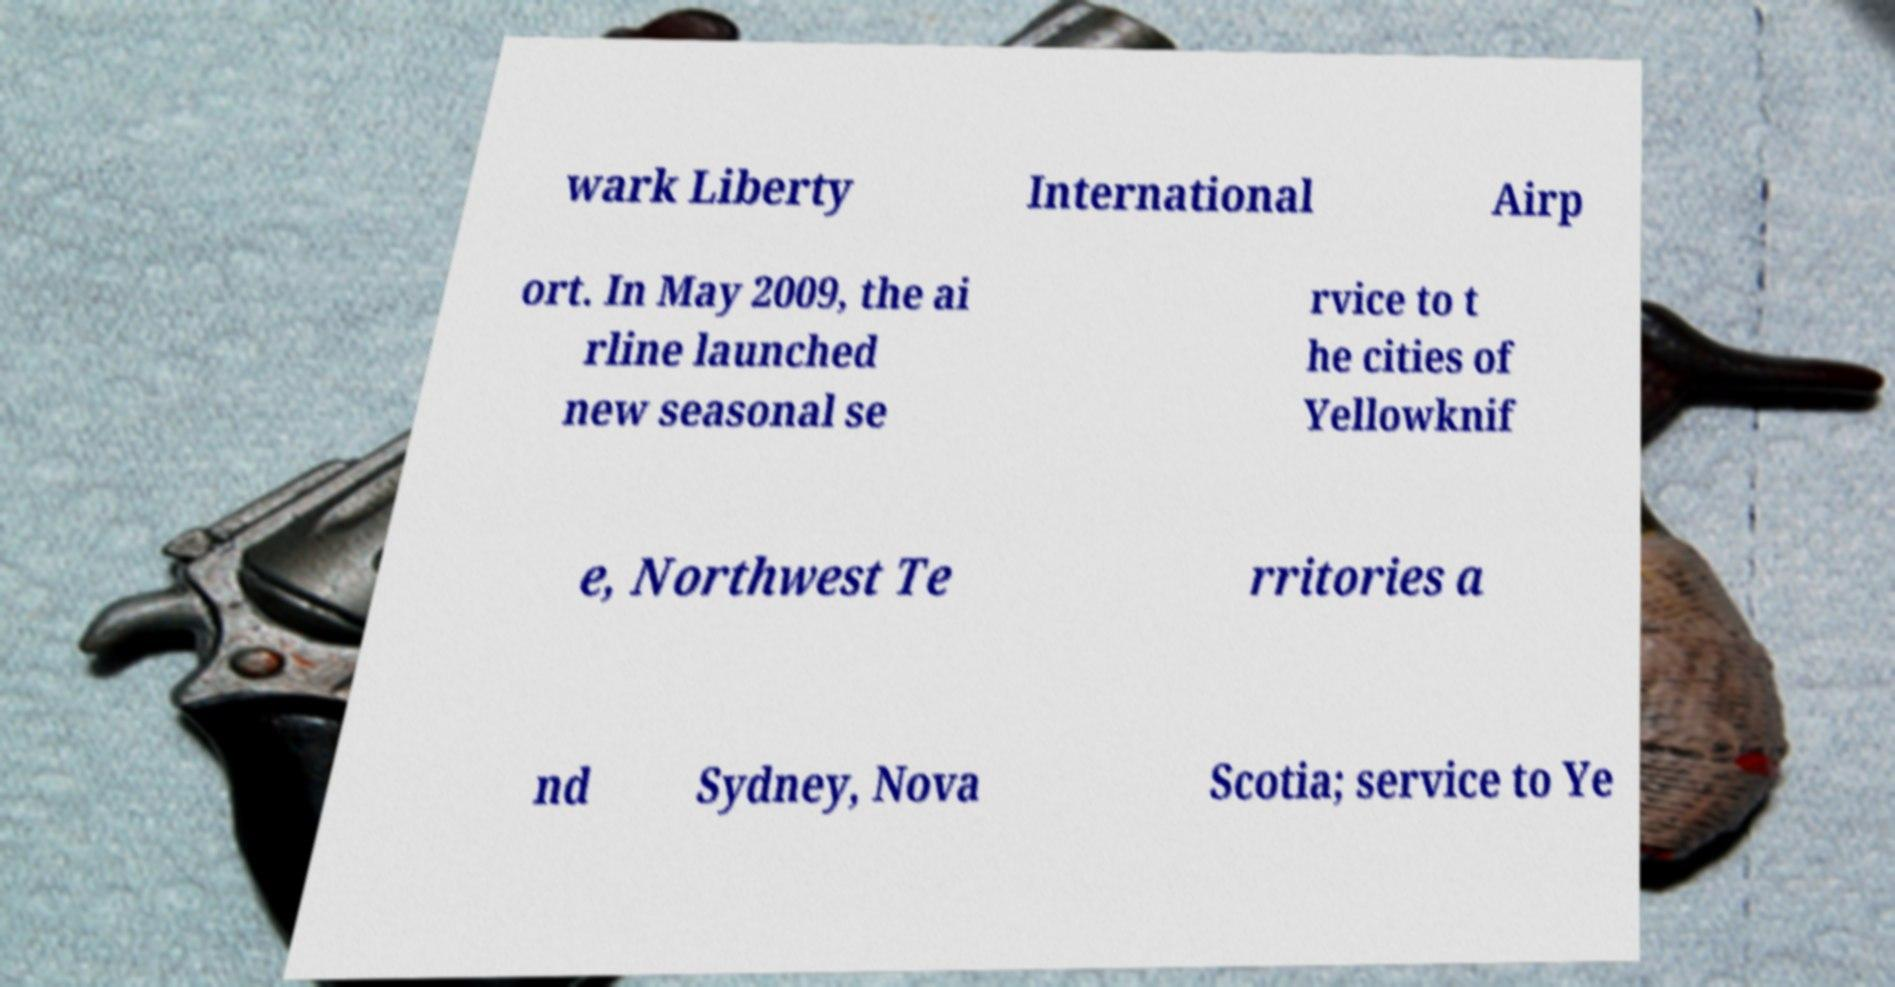Please read and relay the text visible in this image. What does it say? wark Liberty International Airp ort. In May 2009, the ai rline launched new seasonal se rvice to t he cities of Yellowknif e, Northwest Te rritories a nd Sydney, Nova Scotia; service to Ye 